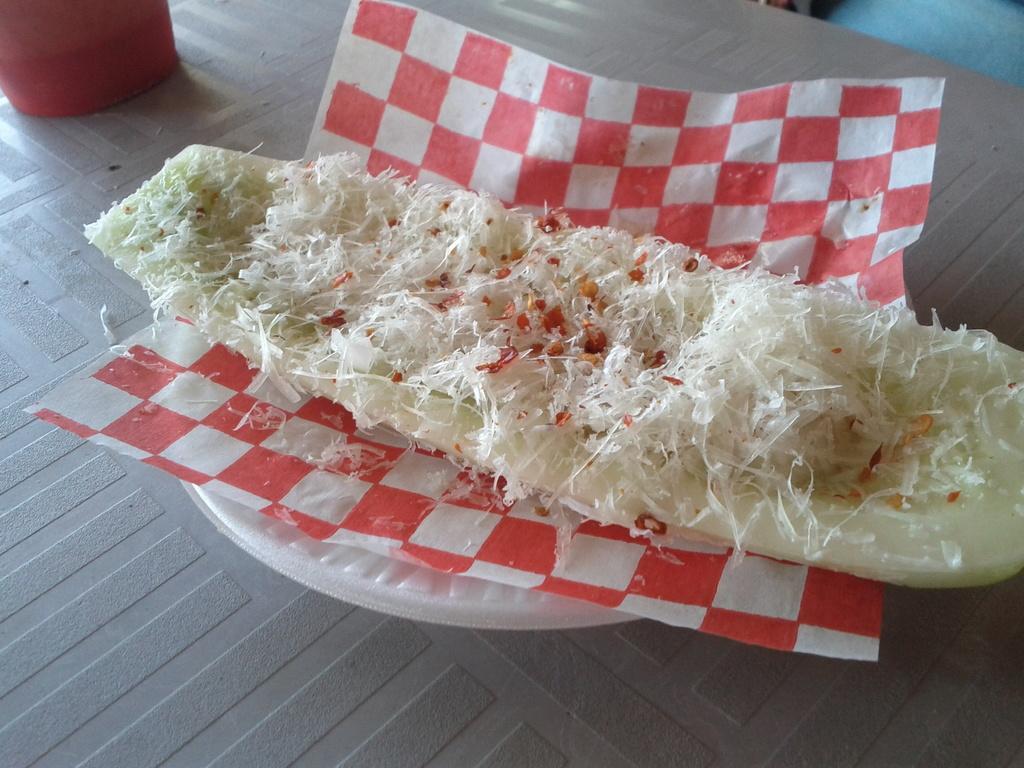Could you give a brief overview of what you see in this image? In this picture there is a food item on a tissue, which is on a bowl and there is a glass at the top side of the image. 